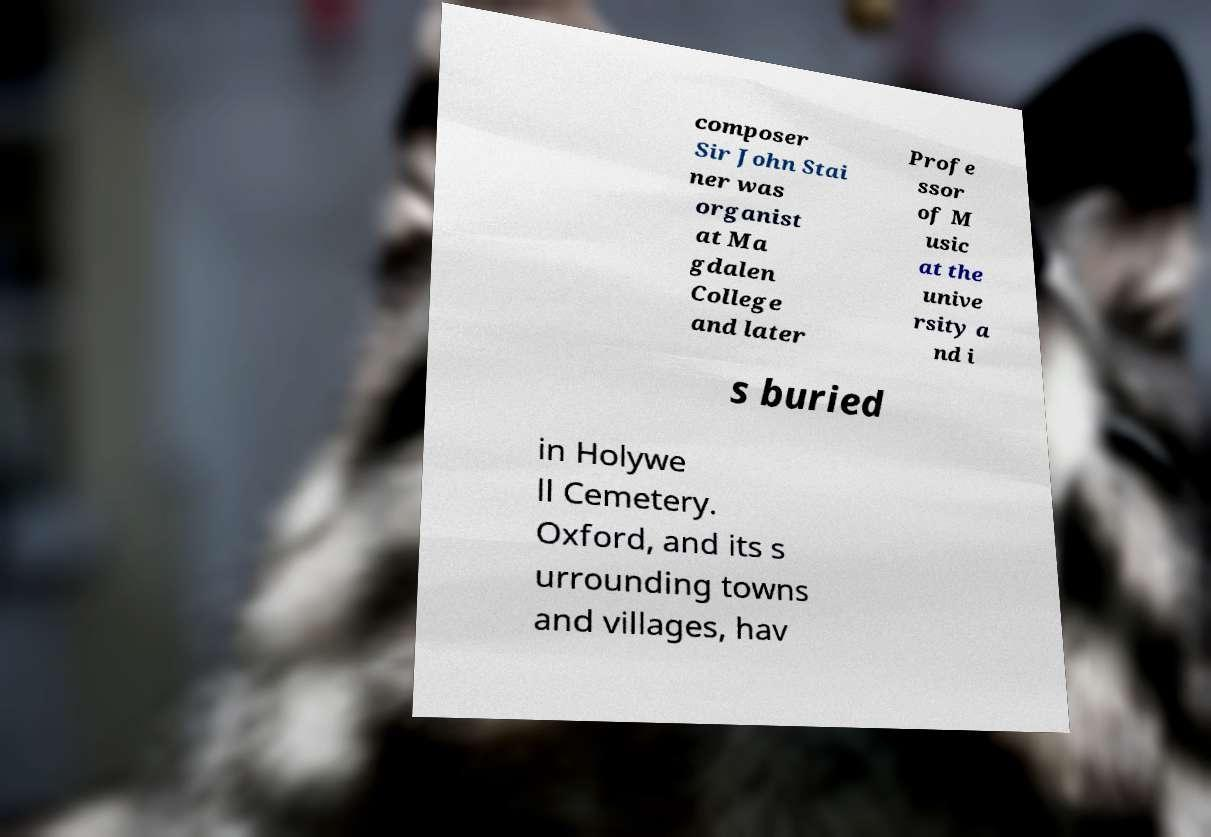I need the written content from this picture converted into text. Can you do that? composer Sir John Stai ner was organist at Ma gdalen College and later Profe ssor of M usic at the unive rsity a nd i s buried in Holywe ll Cemetery. Oxford, and its s urrounding towns and villages, hav 